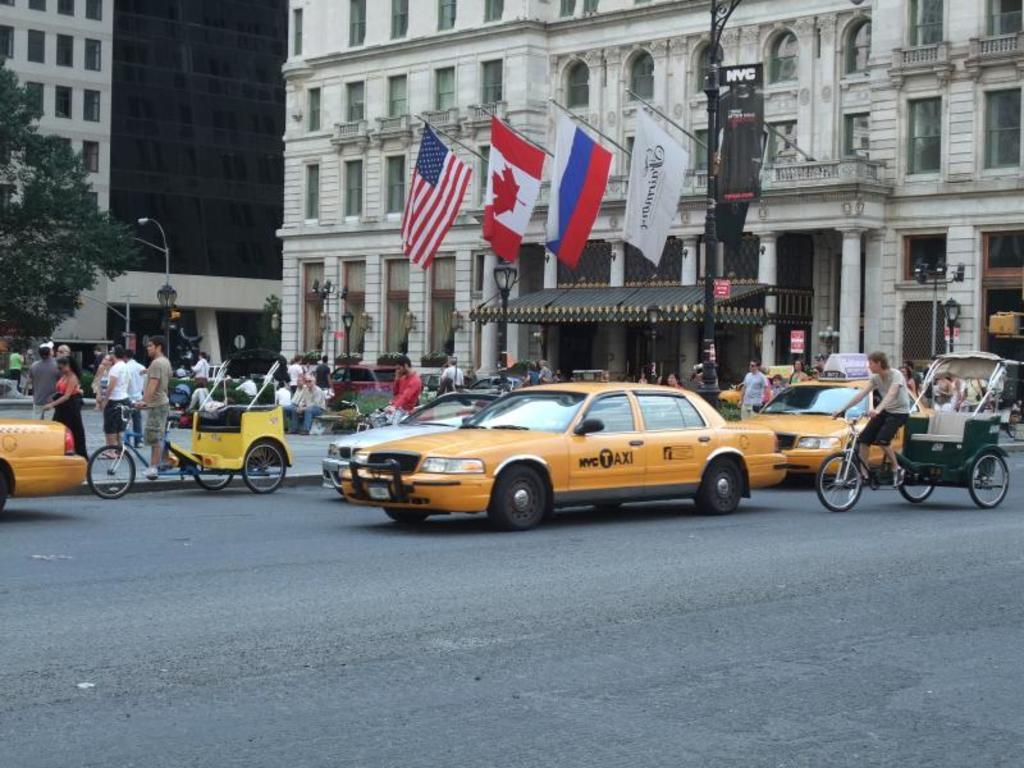Could you give a brief overview of what you see in this image? There is a huge building and it has four flags attached to the balcony of the building, there are many vehicles moving on the road in front of the building and behind the vehicles there are few people beside standing and sitting beside a pole, on the left side there is a tree and behind that tree there is another huge building. 